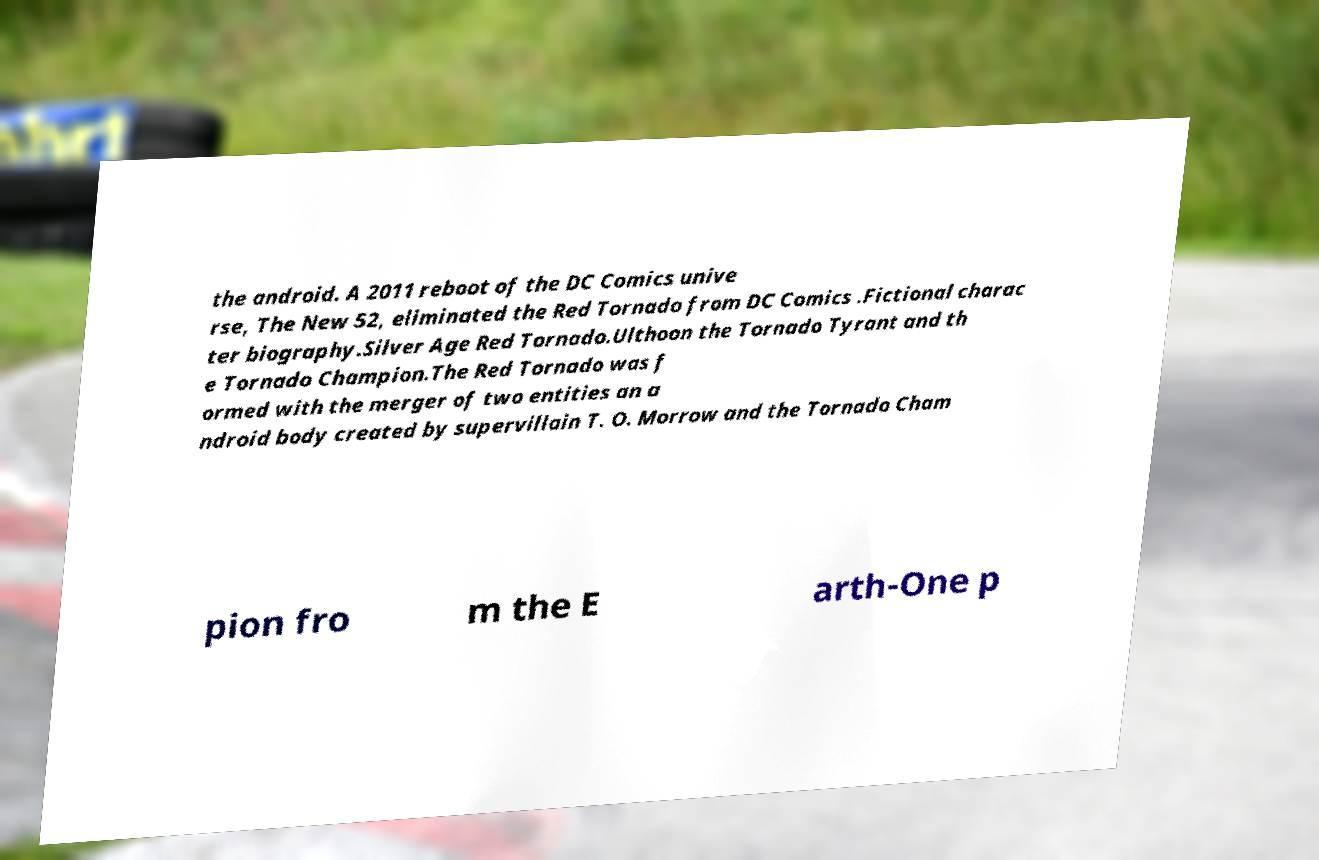Could you assist in decoding the text presented in this image and type it out clearly? the android. A 2011 reboot of the DC Comics unive rse, The New 52, eliminated the Red Tornado from DC Comics .Fictional charac ter biography.Silver Age Red Tornado.Ulthoon the Tornado Tyrant and th e Tornado Champion.The Red Tornado was f ormed with the merger of two entities an a ndroid body created by supervillain T. O. Morrow and the Tornado Cham pion fro m the E arth-One p 